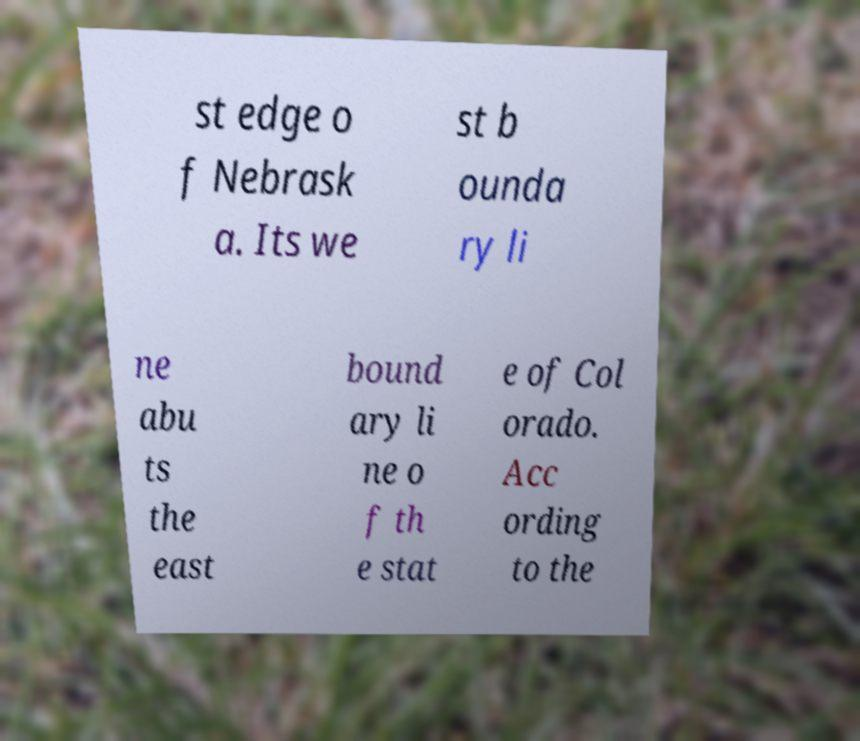Could you assist in decoding the text presented in this image and type it out clearly? st edge o f Nebrask a. Its we st b ounda ry li ne abu ts the east bound ary li ne o f th e stat e of Col orado. Acc ording to the 